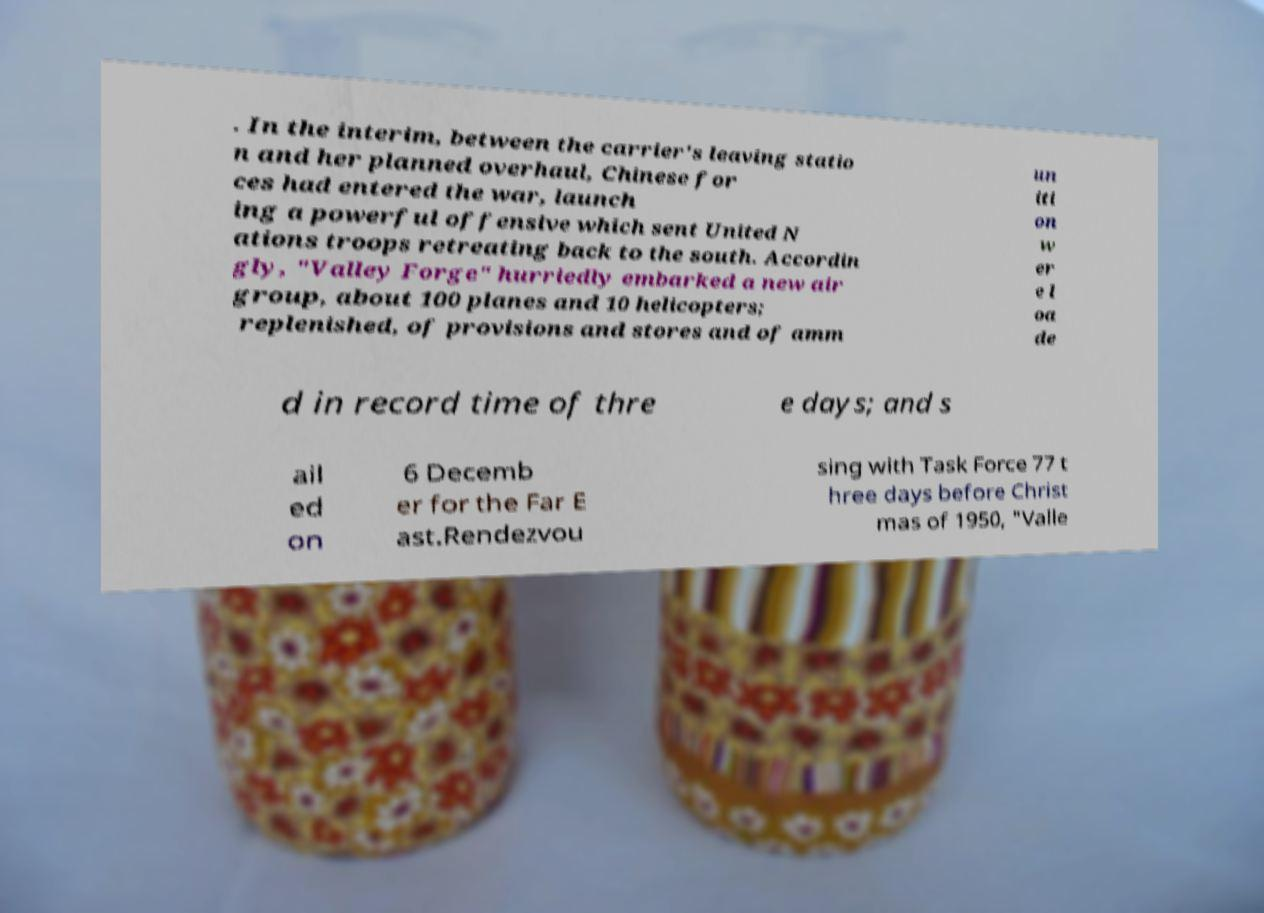Can you accurately transcribe the text from the provided image for me? . In the interim, between the carrier's leaving statio n and her planned overhaul, Chinese for ces had entered the war, launch ing a powerful offensive which sent United N ations troops retreating back to the south. Accordin gly, "Valley Forge" hurriedly embarked a new air group, about 100 planes and 10 helicopters; replenished, of provisions and stores and of amm un iti on w er e l oa de d in record time of thre e days; and s ail ed on 6 Decemb er for the Far E ast.Rendezvou sing with Task Force 77 t hree days before Christ mas of 1950, "Valle 